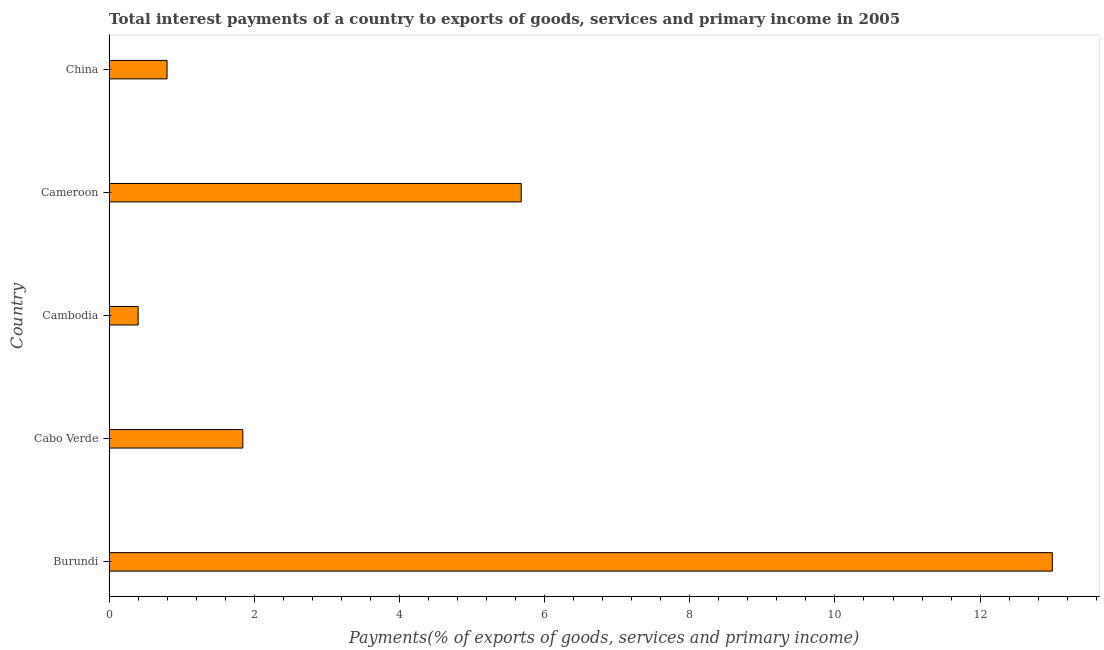What is the title of the graph?
Your answer should be very brief. Total interest payments of a country to exports of goods, services and primary income in 2005. What is the label or title of the X-axis?
Ensure brevity in your answer.  Payments(% of exports of goods, services and primary income). What is the label or title of the Y-axis?
Make the answer very short. Country. What is the total interest payments on external debt in Cambodia?
Provide a short and direct response. 0.4. Across all countries, what is the maximum total interest payments on external debt?
Provide a succinct answer. 13. Across all countries, what is the minimum total interest payments on external debt?
Keep it short and to the point. 0.4. In which country was the total interest payments on external debt maximum?
Your response must be concise. Burundi. In which country was the total interest payments on external debt minimum?
Make the answer very short. Cambodia. What is the sum of the total interest payments on external debt?
Ensure brevity in your answer.  21.72. What is the difference between the total interest payments on external debt in Cameroon and China?
Your answer should be very brief. 4.88. What is the average total interest payments on external debt per country?
Your answer should be very brief. 4.34. What is the median total interest payments on external debt?
Give a very brief answer. 1.84. What is the ratio of the total interest payments on external debt in Cambodia to that in Cameroon?
Provide a succinct answer. 0.07. What is the difference between the highest and the second highest total interest payments on external debt?
Your answer should be very brief. 7.32. Is the sum of the total interest payments on external debt in Burundi and Cambodia greater than the maximum total interest payments on external debt across all countries?
Your answer should be very brief. Yes. What is the difference between the highest and the lowest total interest payments on external debt?
Offer a terse response. 12.59. In how many countries, is the total interest payments on external debt greater than the average total interest payments on external debt taken over all countries?
Provide a short and direct response. 2. How many countries are there in the graph?
Your answer should be very brief. 5. Are the values on the major ticks of X-axis written in scientific E-notation?
Give a very brief answer. No. What is the Payments(% of exports of goods, services and primary income) in Burundi?
Give a very brief answer. 13. What is the Payments(% of exports of goods, services and primary income) in Cabo Verde?
Your answer should be compact. 1.84. What is the Payments(% of exports of goods, services and primary income) in Cambodia?
Your answer should be compact. 0.4. What is the Payments(% of exports of goods, services and primary income) in Cameroon?
Your response must be concise. 5.68. What is the Payments(% of exports of goods, services and primary income) of China?
Offer a very short reply. 0.8. What is the difference between the Payments(% of exports of goods, services and primary income) in Burundi and Cabo Verde?
Your response must be concise. 11.15. What is the difference between the Payments(% of exports of goods, services and primary income) in Burundi and Cambodia?
Give a very brief answer. 12.59. What is the difference between the Payments(% of exports of goods, services and primary income) in Burundi and Cameroon?
Your answer should be compact. 7.32. What is the difference between the Payments(% of exports of goods, services and primary income) in Burundi and China?
Your answer should be very brief. 12.2. What is the difference between the Payments(% of exports of goods, services and primary income) in Cabo Verde and Cambodia?
Make the answer very short. 1.44. What is the difference between the Payments(% of exports of goods, services and primary income) in Cabo Verde and Cameroon?
Provide a succinct answer. -3.84. What is the difference between the Payments(% of exports of goods, services and primary income) in Cabo Verde and China?
Offer a very short reply. 1.04. What is the difference between the Payments(% of exports of goods, services and primary income) in Cambodia and Cameroon?
Provide a short and direct response. -5.28. What is the difference between the Payments(% of exports of goods, services and primary income) in Cambodia and China?
Provide a short and direct response. -0.4. What is the difference between the Payments(% of exports of goods, services and primary income) in Cameroon and China?
Your answer should be compact. 4.88. What is the ratio of the Payments(% of exports of goods, services and primary income) in Burundi to that in Cabo Verde?
Provide a succinct answer. 7.05. What is the ratio of the Payments(% of exports of goods, services and primary income) in Burundi to that in Cambodia?
Your answer should be very brief. 32.44. What is the ratio of the Payments(% of exports of goods, services and primary income) in Burundi to that in Cameroon?
Offer a terse response. 2.29. What is the ratio of the Payments(% of exports of goods, services and primary income) in Burundi to that in China?
Make the answer very short. 16.27. What is the ratio of the Payments(% of exports of goods, services and primary income) in Cabo Verde to that in Cambodia?
Offer a terse response. 4.6. What is the ratio of the Payments(% of exports of goods, services and primary income) in Cabo Verde to that in Cameroon?
Provide a succinct answer. 0.33. What is the ratio of the Payments(% of exports of goods, services and primary income) in Cabo Verde to that in China?
Keep it short and to the point. 2.31. What is the ratio of the Payments(% of exports of goods, services and primary income) in Cambodia to that in Cameroon?
Give a very brief answer. 0.07. What is the ratio of the Payments(% of exports of goods, services and primary income) in Cambodia to that in China?
Your answer should be very brief. 0.5. What is the ratio of the Payments(% of exports of goods, services and primary income) in Cameroon to that in China?
Provide a short and direct response. 7.11. 